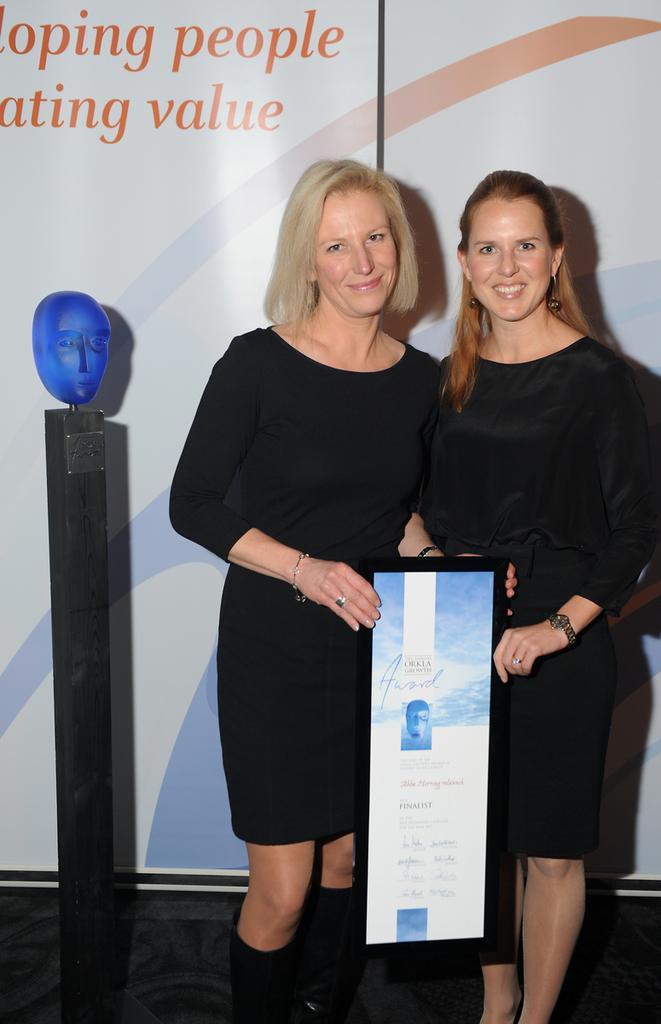How would you summarize this image in a sentence or two? In this picture we can see two women are holding a board, behind we can see a banner on which some words are written. 